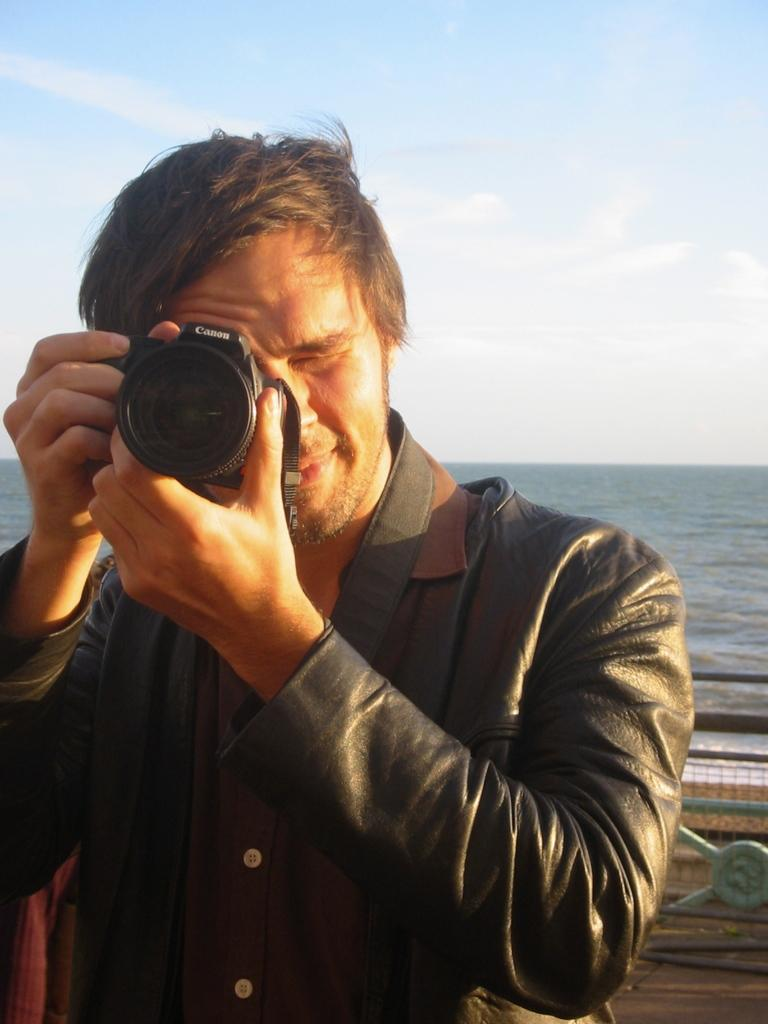What is the man in the image doing? The man is holding a camera in the image. What can be seen in the background of the image? There is water visible in the image. What type of noise can be heard coming from the wrench in the image? There is no wrench present in the image, so it is not possible to determine what, if any, noise might be heard. 